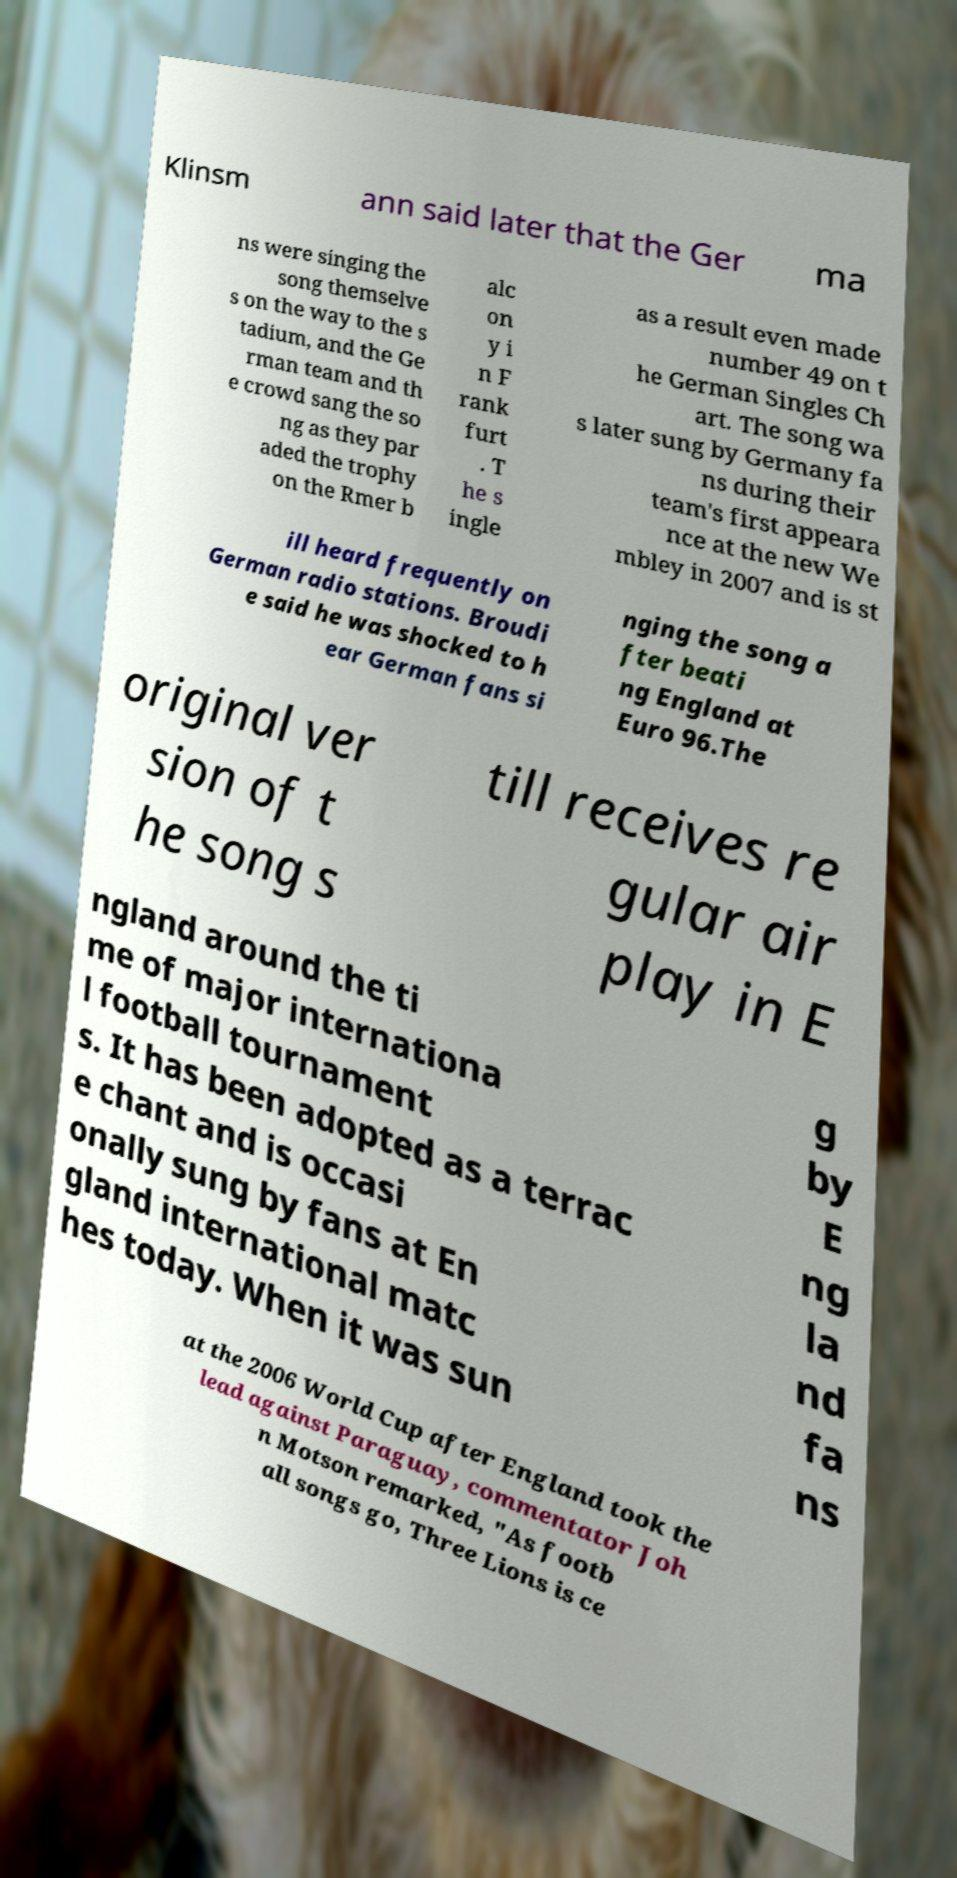What messages or text are displayed in this image? I need them in a readable, typed format. Klinsm ann said later that the Ger ma ns were singing the song themselve s on the way to the s tadium, and the Ge rman team and th e crowd sang the so ng as they par aded the trophy on the Rmer b alc on y i n F rank furt . T he s ingle as a result even made number 49 on t he German Singles Ch art. The song wa s later sung by Germany fa ns during their team's first appeara nce at the new We mbley in 2007 and is st ill heard frequently on German radio stations. Broudi e said he was shocked to h ear German fans si nging the song a fter beati ng England at Euro 96.The original ver sion of t he song s till receives re gular air play in E ngland around the ti me of major internationa l football tournament s. It has been adopted as a terrac e chant and is occasi onally sung by fans at En gland international matc hes today. When it was sun g by E ng la nd fa ns at the 2006 World Cup after England took the lead against Paraguay, commentator Joh n Motson remarked, "As footb all songs go, Three Lions is ce 